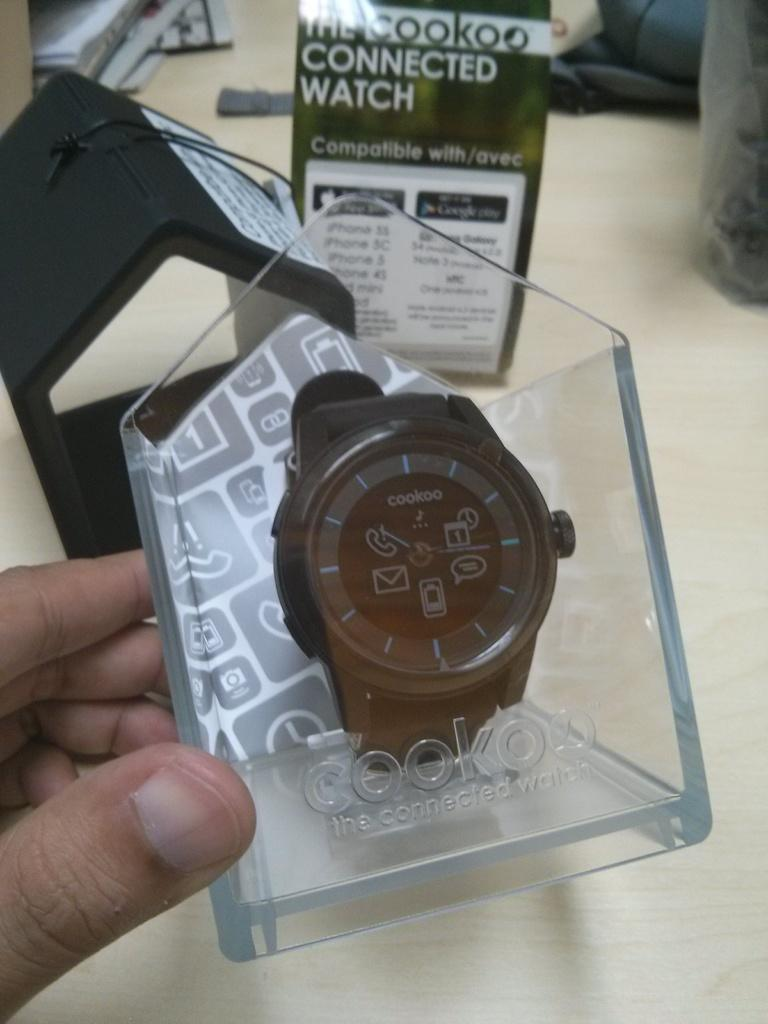<image>
Give a short and clear explanation of the subsequent image. The rd and black cookoo brand wrist watc in display holder case 